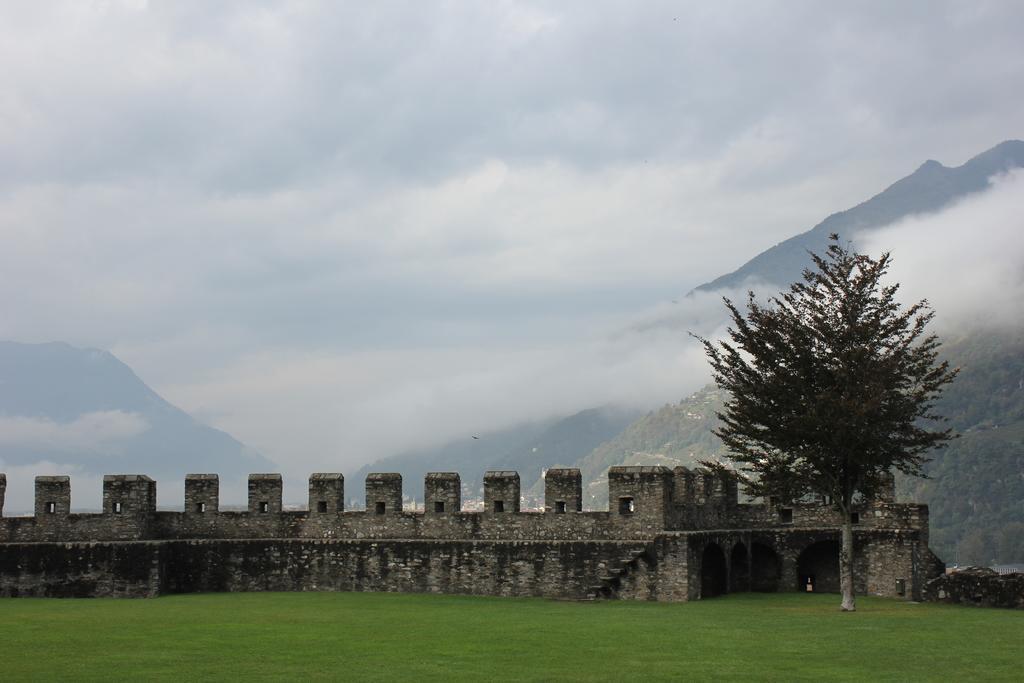How would you summarize this image in a sentence or two? In the image in the center, we can see the sky, clouds, trees, grass and compound wall. 